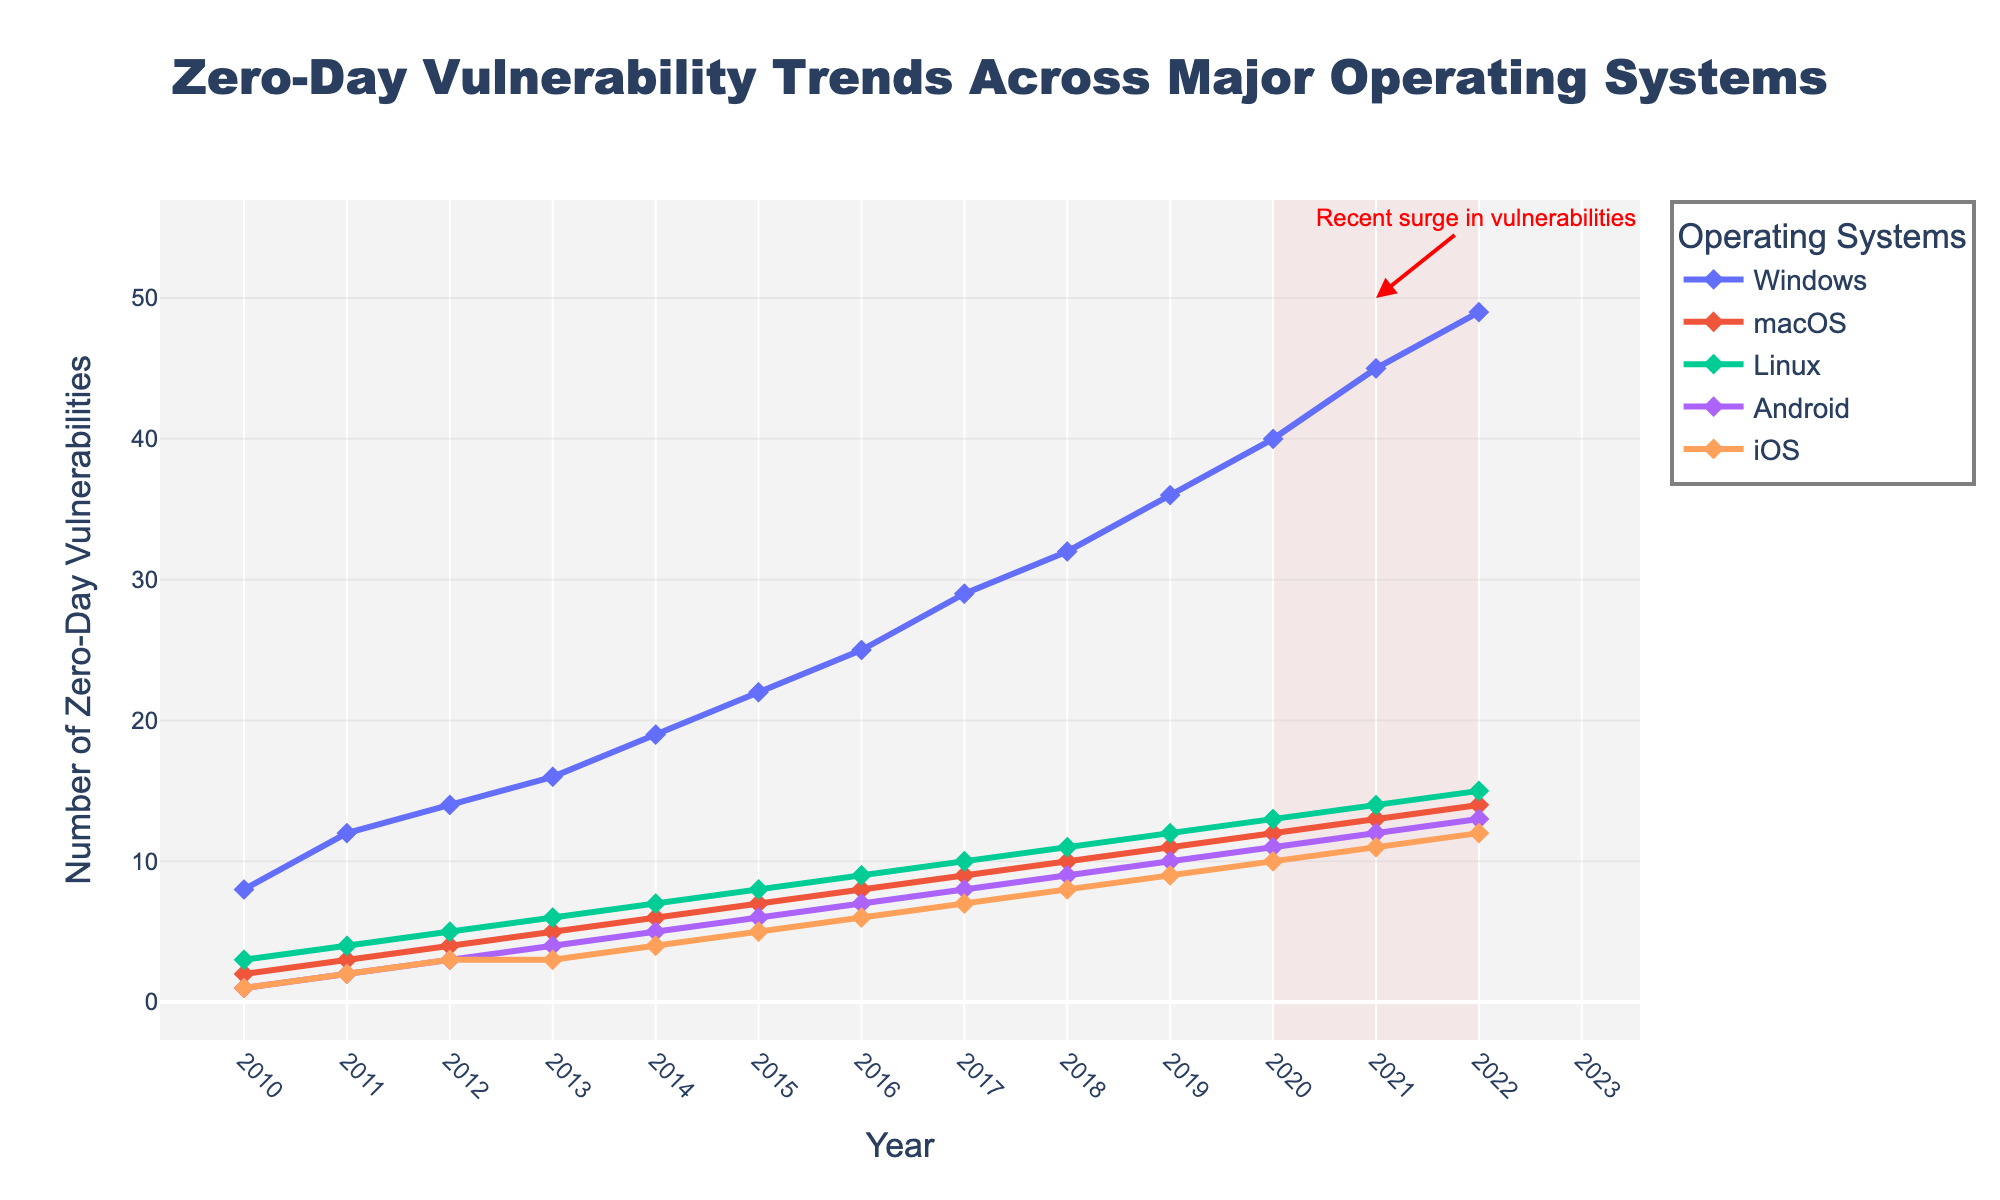What is the trend for zero-day vulnerabilities for Windows from 2010 to 2022? By observing the line representing Windows, it continually increases from 8 in 2010 to 49 in 2022, indicating a rising trend in zero-day vulnerabilities over the years.
Answer: The trend is rising Which operating system saw the least increase in zero-day vulnerabilities from 2010 to 2022? To find the least increase, subtract 2010 values from those in 2022 for each OS. The increase for macOS (14-2=12) is the smallest compared to others.
Answer: macOS By how much did the number of zero-day vulnerabilities in Android increase from 2010 to 2015? In 2010, Android had 1 zero-day vulnerability, and in 2015 it had 6. The increase is 6 - 1 = 5.
Answer: 5 Which operating system had more zero-day vulnerabilities in 2020, Linux or iOS? Compare the values for Linux and iOS in 2020. Linux had 13, and iOS had 10, so Linux had more.
Answer: Linux What is the average number of zero-day vulnerabilities for Android between 2018 and 2022? Add the values for 2018 (9), 2019 (10), 2020 (11), 2021 (12), and 2022 (13) which sums to 55. The average is then 55 / 5 = 11.
Answer: 11 During the highlighted period (2020-2022), which operating system showed the steepest increase in zero-day vulnerabilities? Analyze the differences from 2020 to 2022 for each OS. Windows increased from 40 to 49 (+9), which is the steepest when compared with others.
Answer: Windows Visualize the graph: which operating system line is steeper between 2017 and 2019, macOS or iOS? Visually, the slope of the line for macOS from 2017 (9) to 2019 (11) is less steep compared to iOS from 2017 (7) to 2019 (9).
Answer: iOS How many zero-day vulnerabilities combined do macOS and Linux have in 2014? In 2014, macOS has 6 and Linux has 7, so combined they have 6 + 7 = 13.
Answer: 13 Which operating system has the closest number of zero-day vulnerabilities to Windows in 2022? In 2022, Windows has 49. The closest is macOS with 14, Linux with 15, Android with 13, and iOS with 12. The closest difference is Windows (49) - Linux (15) = 34.
Answer: Linux 